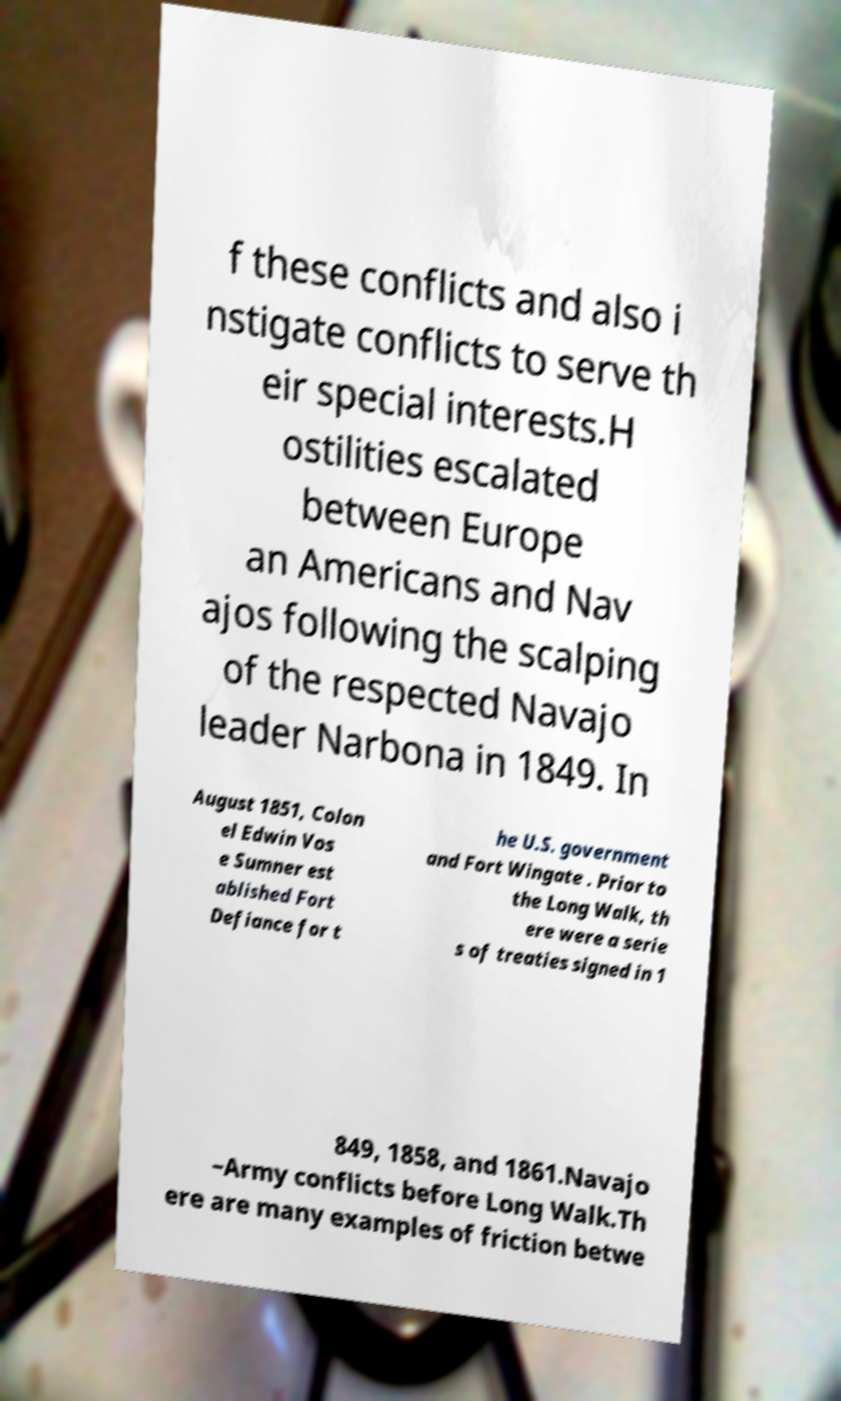For documentation purposes, I need the text within this image transcribed. Could you provide that? f these conflicts and also i nstigate conflicts to serve th eir special interests.H ostilities escalated between Europe an Americans and Nav ajos following the scalping of the respected Navajo leader Narbona in 1849. In August 1851, Colon el Edwin Vos e Sumner est ablished Fort Defiance for t he U.S. government and Fort Wingate . Prior to the Long Walk, th ere were a serie s of treaties signed in 1 849, 1858, and 1861.Navajo –Army conflicts before Long Walk.Th ere are many examples of friction betwe 